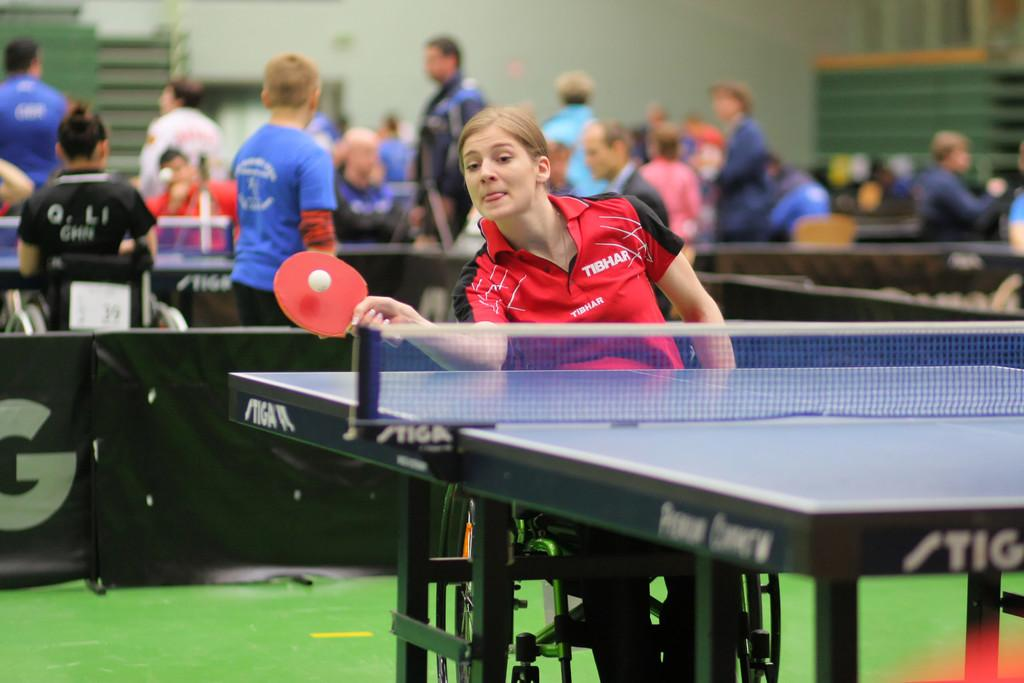Who is the main subject in the image? There is a woman in the image. What is the woman doing in the image? The woman is playing table tennis. How is the woman positioned in the image? The woman is sitting on a wheelchair. What object is the woman holding in her hand? The woman is holding a racket in her hand. What can be seen in the background of the image? There is a fence visible in the image. Are there any other people present in the image? Yes, there is a group of people in the image. What type of desk can be seen in the image? There is no desk present in the image. What type of prose is being recited by the woman in the image? The woman is playing table tennis, not reciting any prose, so it cannot be determined from the image. 